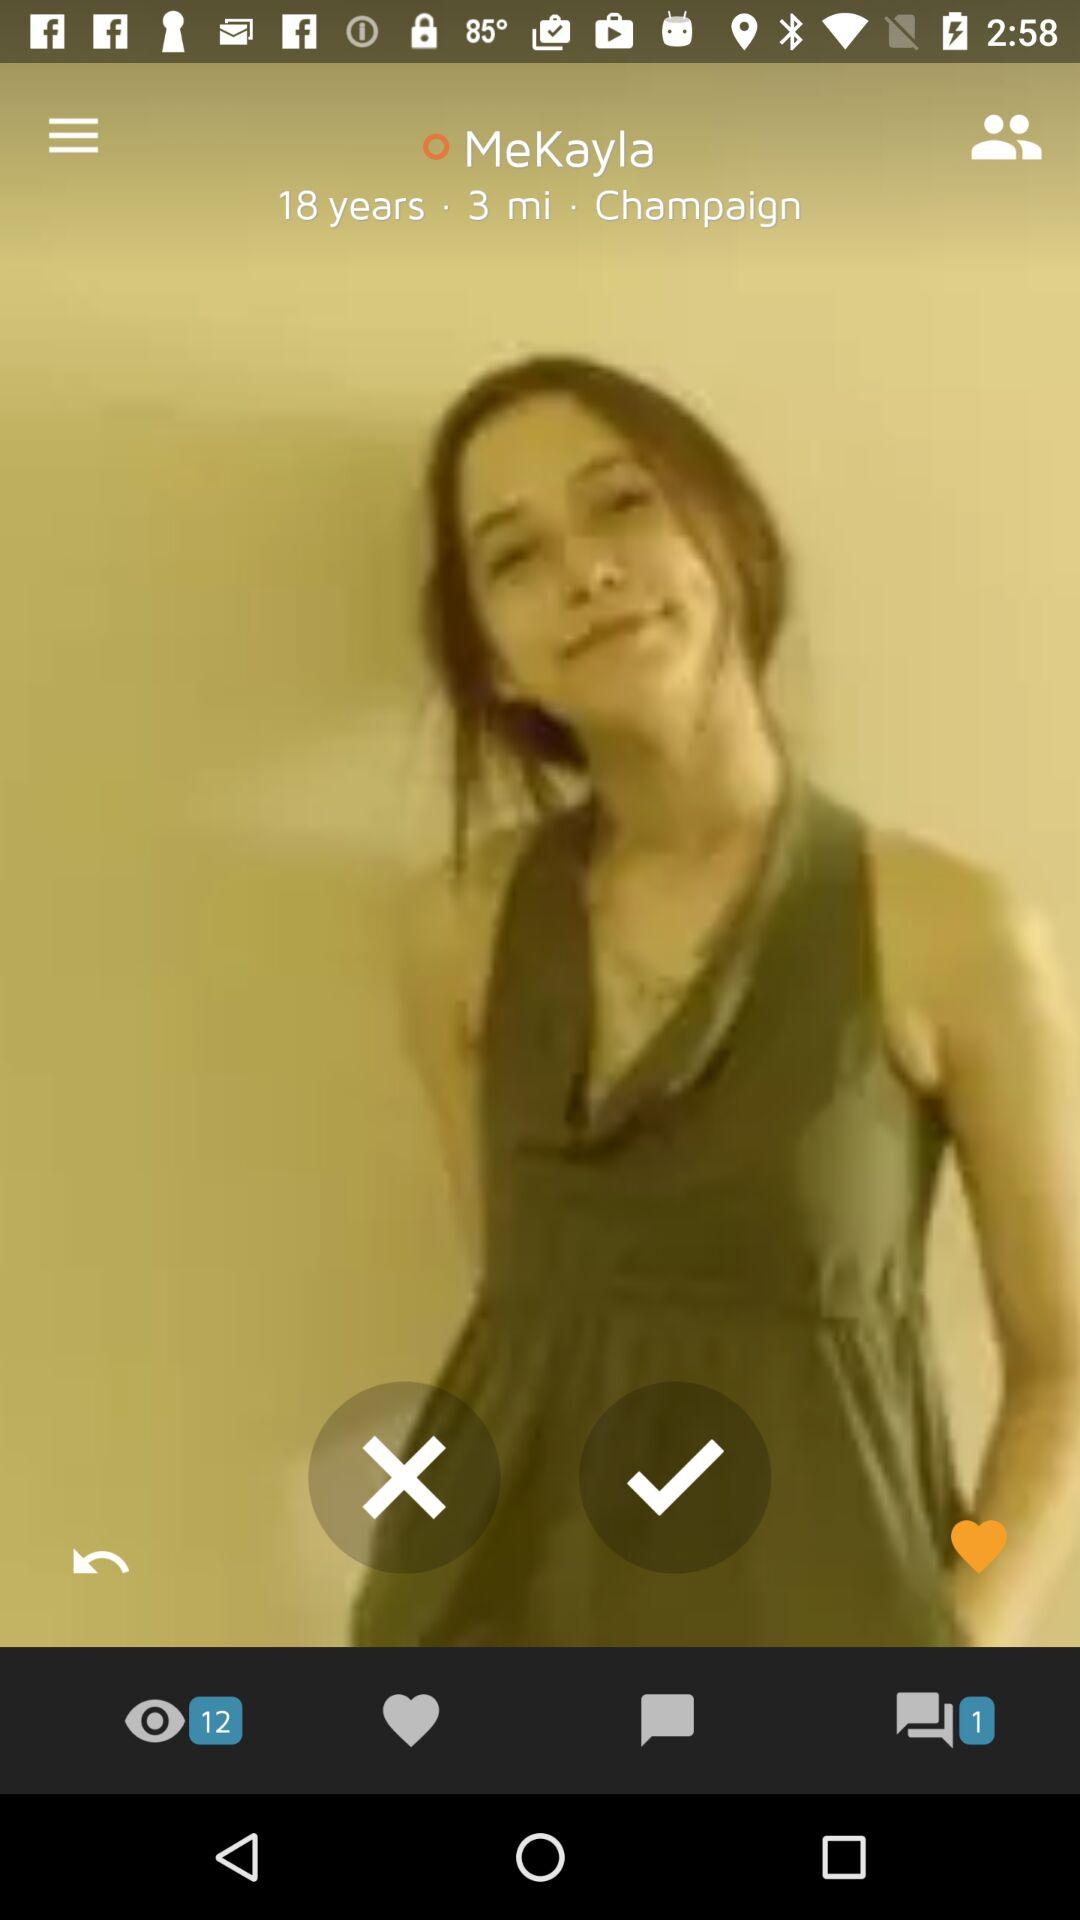MeKayla belongs to what city? MeKayla belongs to Champaign City. 